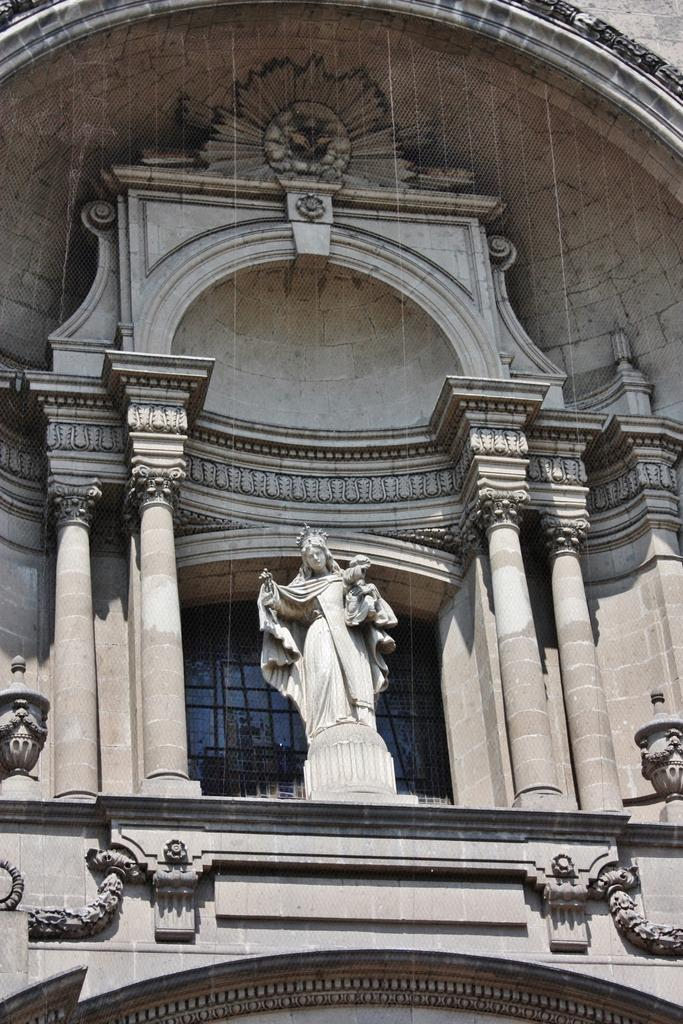What is the main subject in the image? There is a statue in the image. What architectural features can be seen in the image? There are pillars in the image. What type of plantation is depicted in the image? There is no plantation present in the image; it features a statue and pillars. What learning materials can be seen in the image? There are no learning materials present in the image; it features a statue and pillars. 